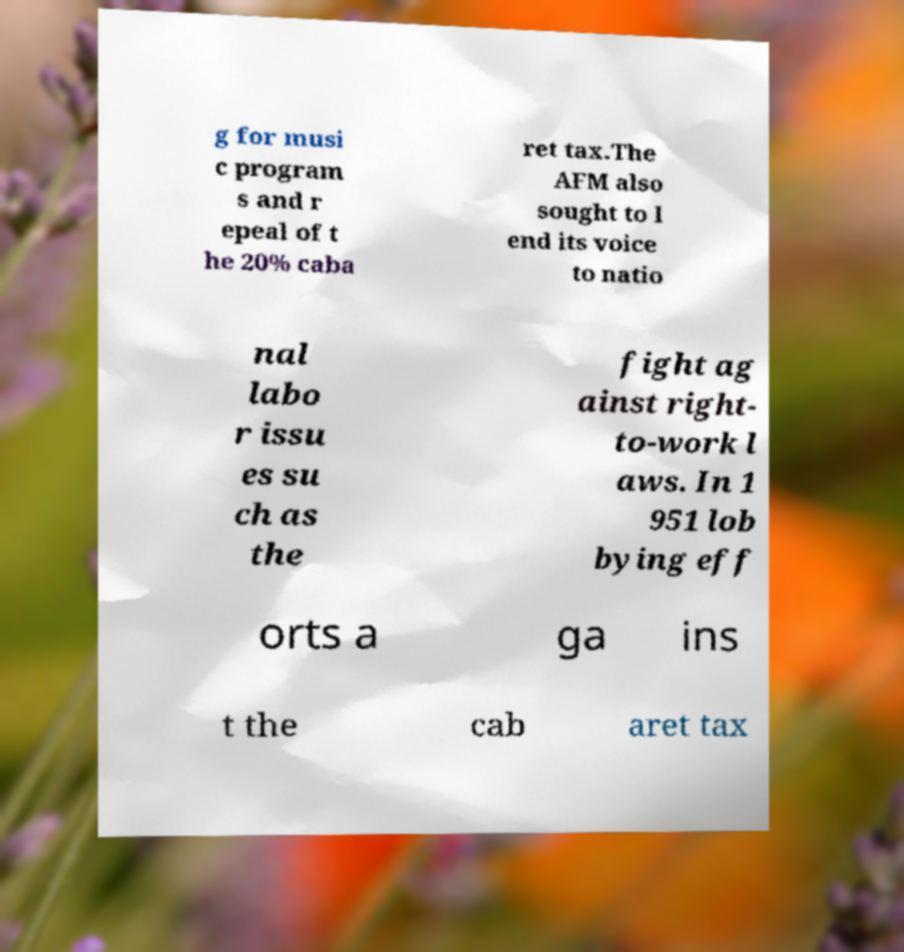I need the written content from this picture converted into text. Can you do that? g for musi c program s and r epeal of t he 20% caba ret tax.The AFM also sought to l end its voice to natio nal labo r issu es su ch as the fight ag ainst right- to-work l aws. In 1 951 lob bying eff orts a ga ins t the cab aret tax 